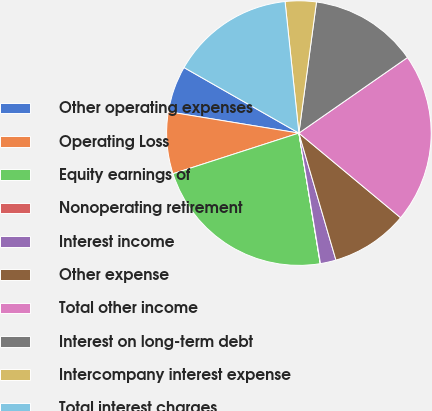<chart> <loc_0><loc_0><loc_500><loc_500><pie_chart><fcel>Other operating expenses<fcel>Operating Loss<fcel>Equity earnings of<fcel>Nonoperating retirement<fcel>Interest income<fcel>Other expense<fcel>Total other income<fcel>Interest on long-term debt<fcel>Intercompany interest expense<fcel>Total interest charges<nl><fcel>5.67%<fcel>7.55%<fcel>22.61%<fcel>0.03%<fcel>1.91%<fcel>9.44%<fcel>20.72%<fcel>13.2%<fcel>3.79%<fcel>15.08%<nl></chart> 